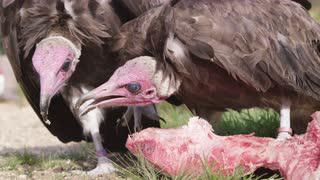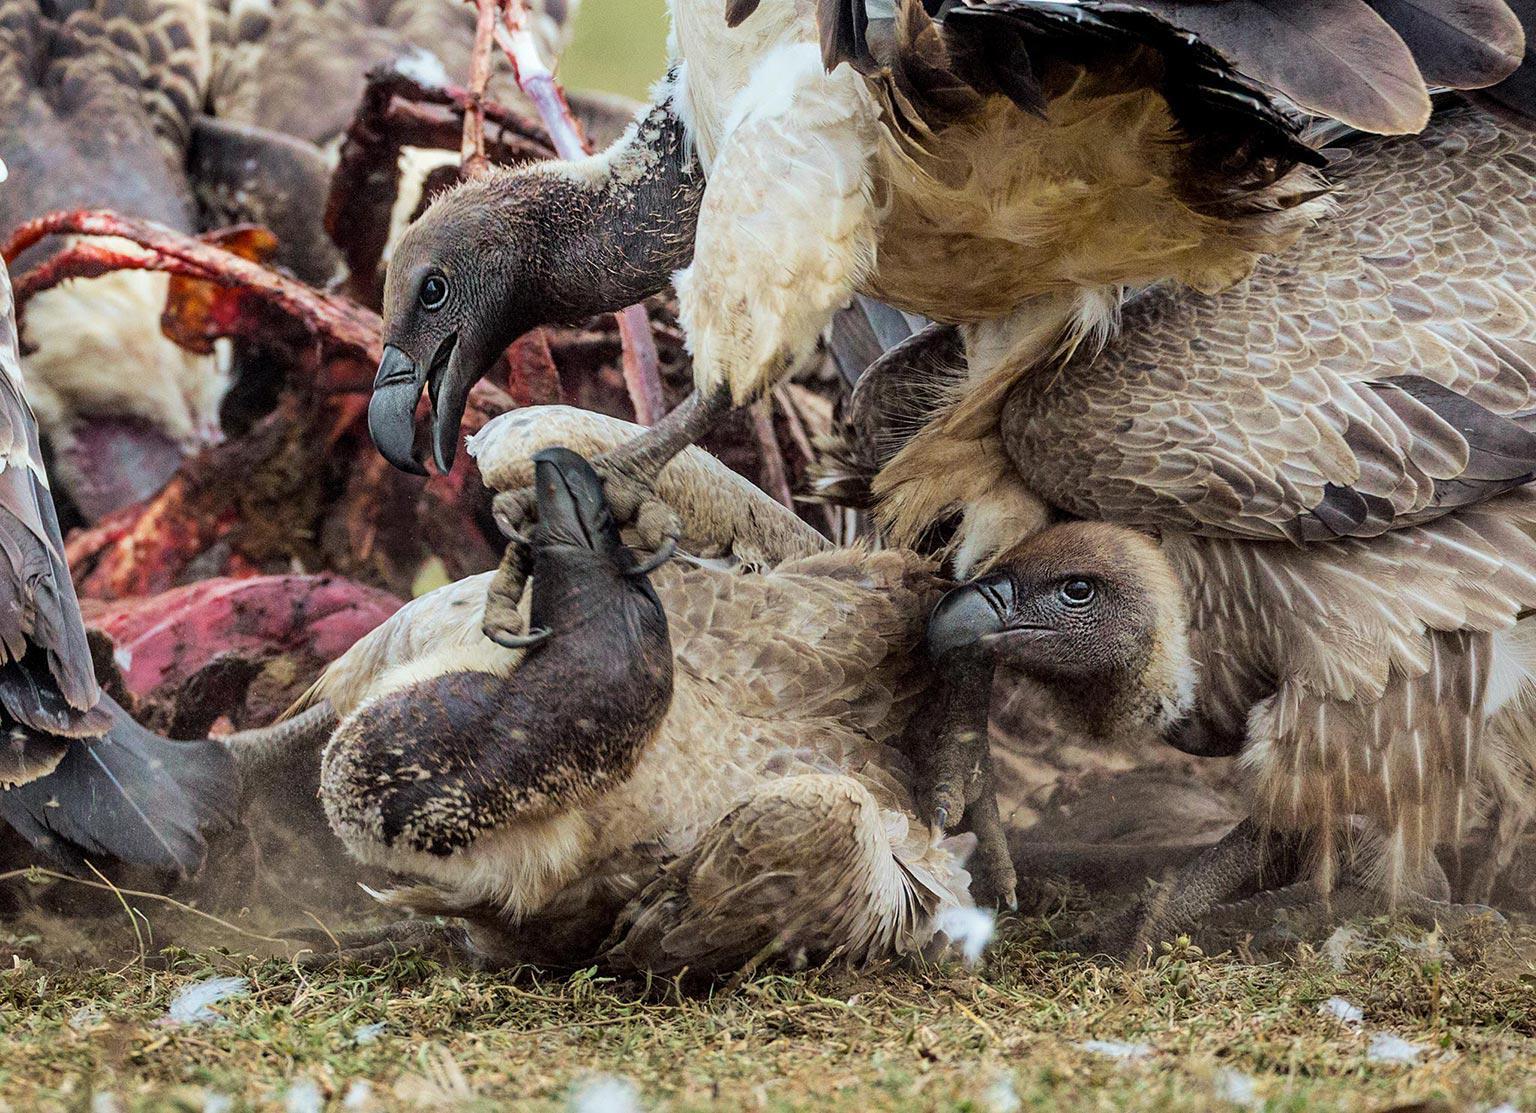The first image is the image on the left, the second image is the image on the right. Examine the images to the left and right. Is the description "An image shows vultures around a zebra carcass with some of its striped hide visible." accurate? Answer yes or no. No. The first image is the image on the left, the second image is the image on the right. Given the left and right images, does the statement "The birds can be seen picking at the striped fur and remains of a zebra in one of the images." hold true? Answer yes or no. No. 